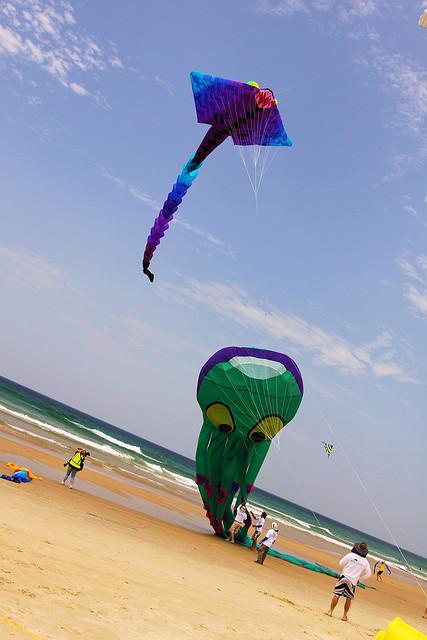How many kites in the picture?
Short answer required. 3. How old are these kids?
Short answer required. 7. What color is the sky?
Answer briefly. Blue. 